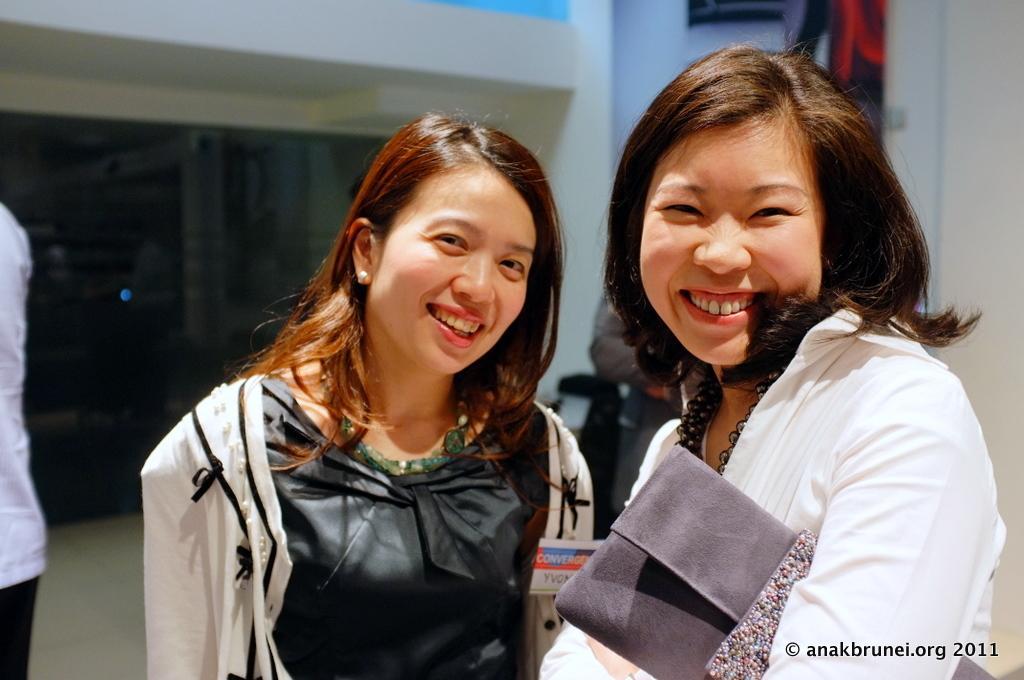Describe this image in one or two sentences. In this picture I can see 2 women standing in front and I see that they're smiling and the woman on the right is carrying a thing. On the left side of this picture I can see a person standing. In the background I can see the wall and I can also see another person standing. On the bottom right corner of this picture I can see the watermark. 